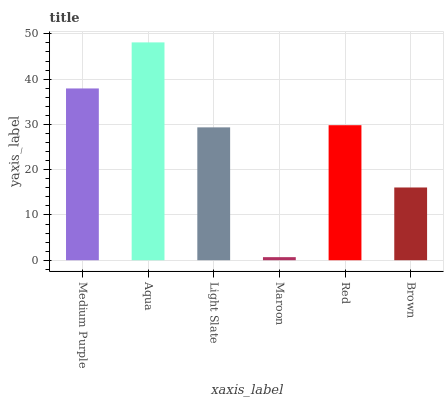Is Maroon the minimum?
Answer yes or no. Yes. Is Aqua the maximum?
Answer yes or no. Yes. Is Light Slate the minimum?
Answer yes or no. No. Is Light Slate the maximum?
Answer yes or no. No. Is Aqua greater than Light Slate?
Answer yes or no. Yes. Is Light Slate less than Aqua?
Answer yes or no. Yes. Is Light Slate greater than Aqua?
Answer yes or no. No. Is Aqua less than Light Slate?
Answer yes or no. No. Is Red the high median?
Answer yes or no. Yes. Is Light Slate the low median?
Answer yes or no. Yes. Is Maroon the high median?
Answer yes or no. No. Is Aqua the low median?
Answer yes or no. No. 